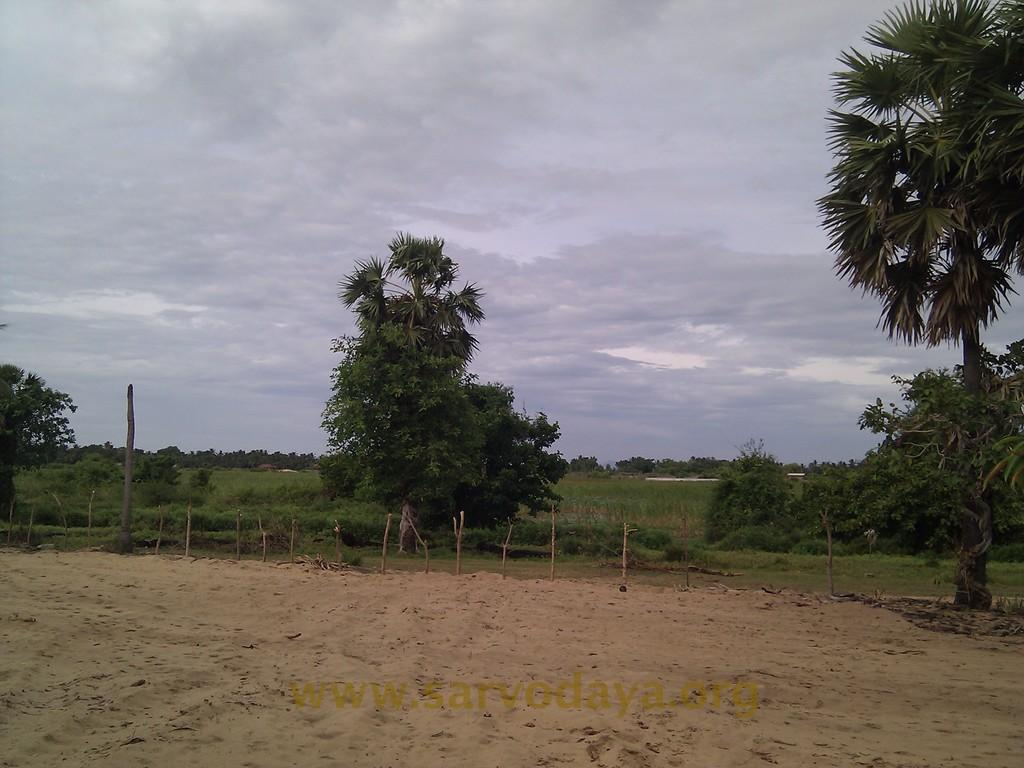What can be seen in the image that resembles a series of vertical structures? There is a group of poles in the image. What type of natural vegetation is present in the image? There are trees in the image. How would you describe the sky in the image? The sky is cloudy in the image. Is there any text visible in the image? Yes, there is text visible at the bottom of the image. How many zinc hydrants can be seen in the image? There are no zinc hydrants present in the image. What type of trucks are visible in the image? There are no trucks present in the image. 